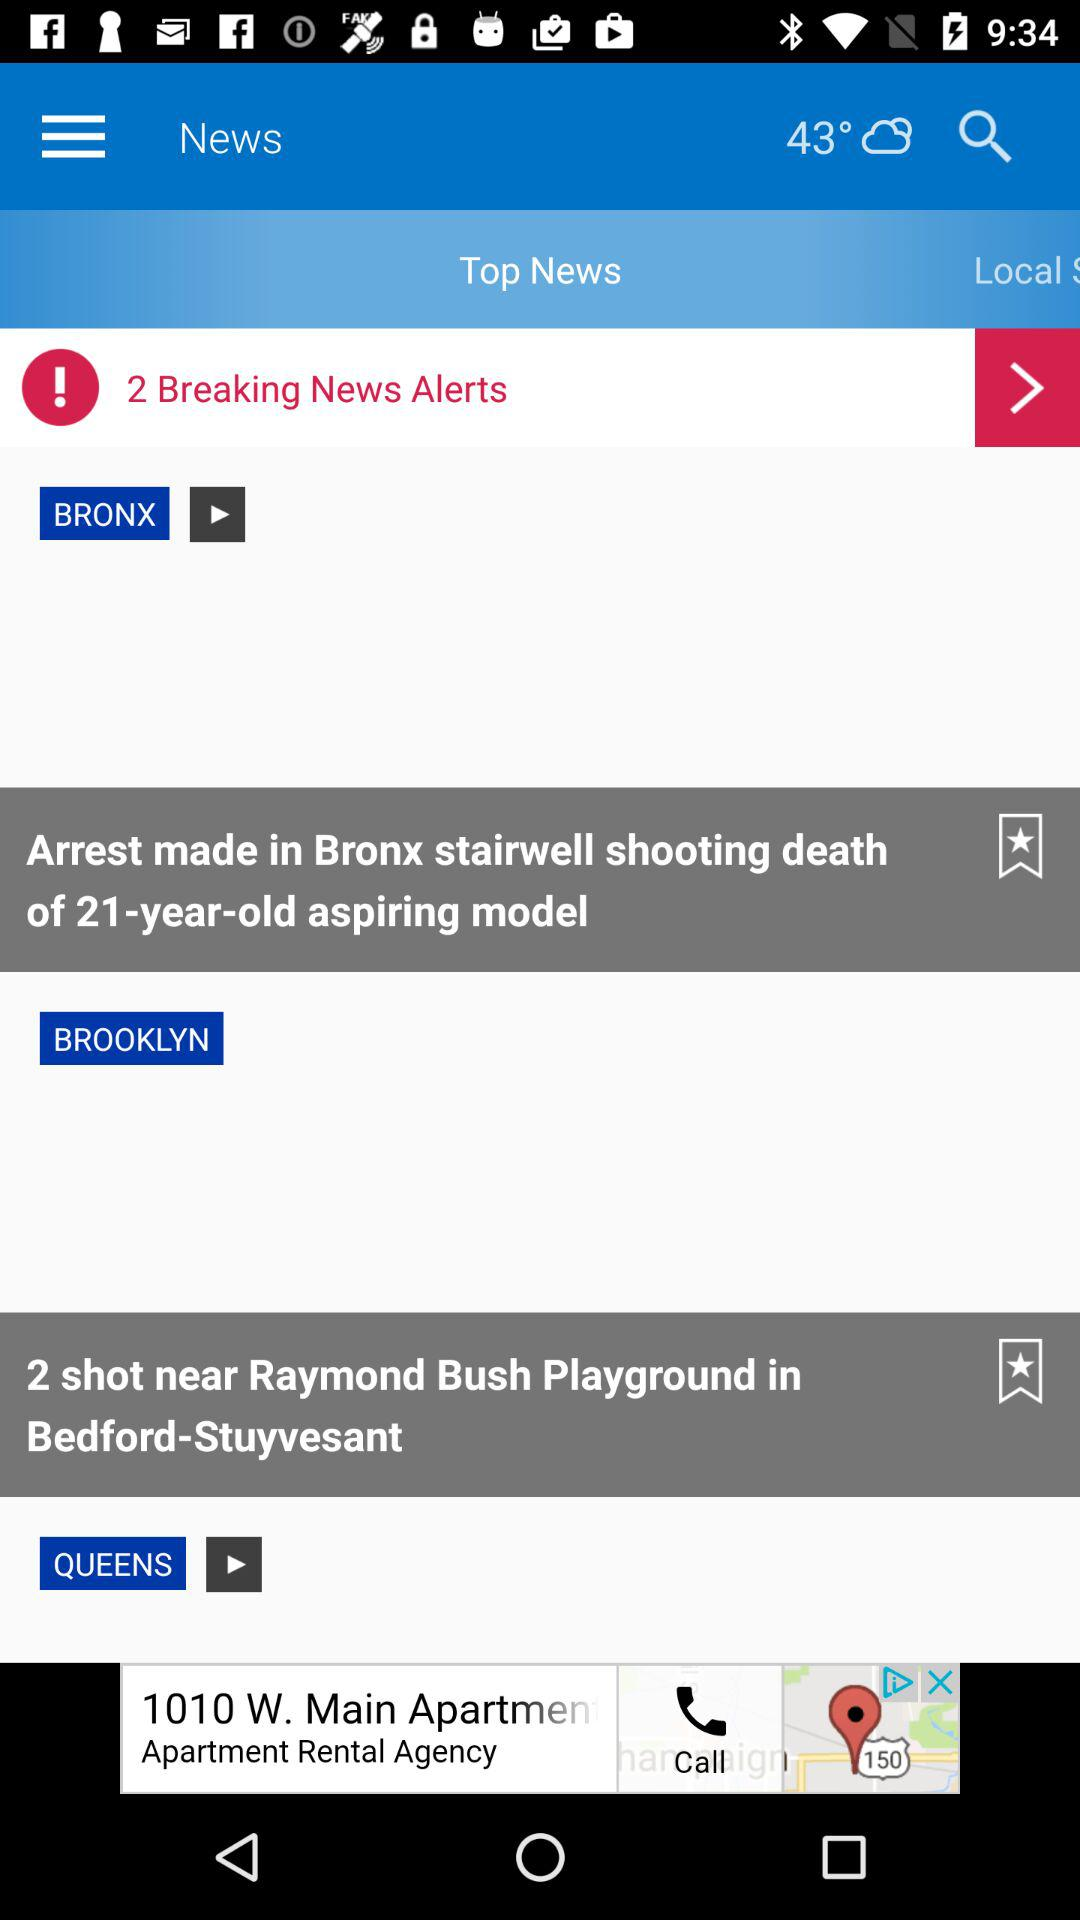What is the age of the model shot to death in Bronx stairwell? The age of the model is 21 years old. 